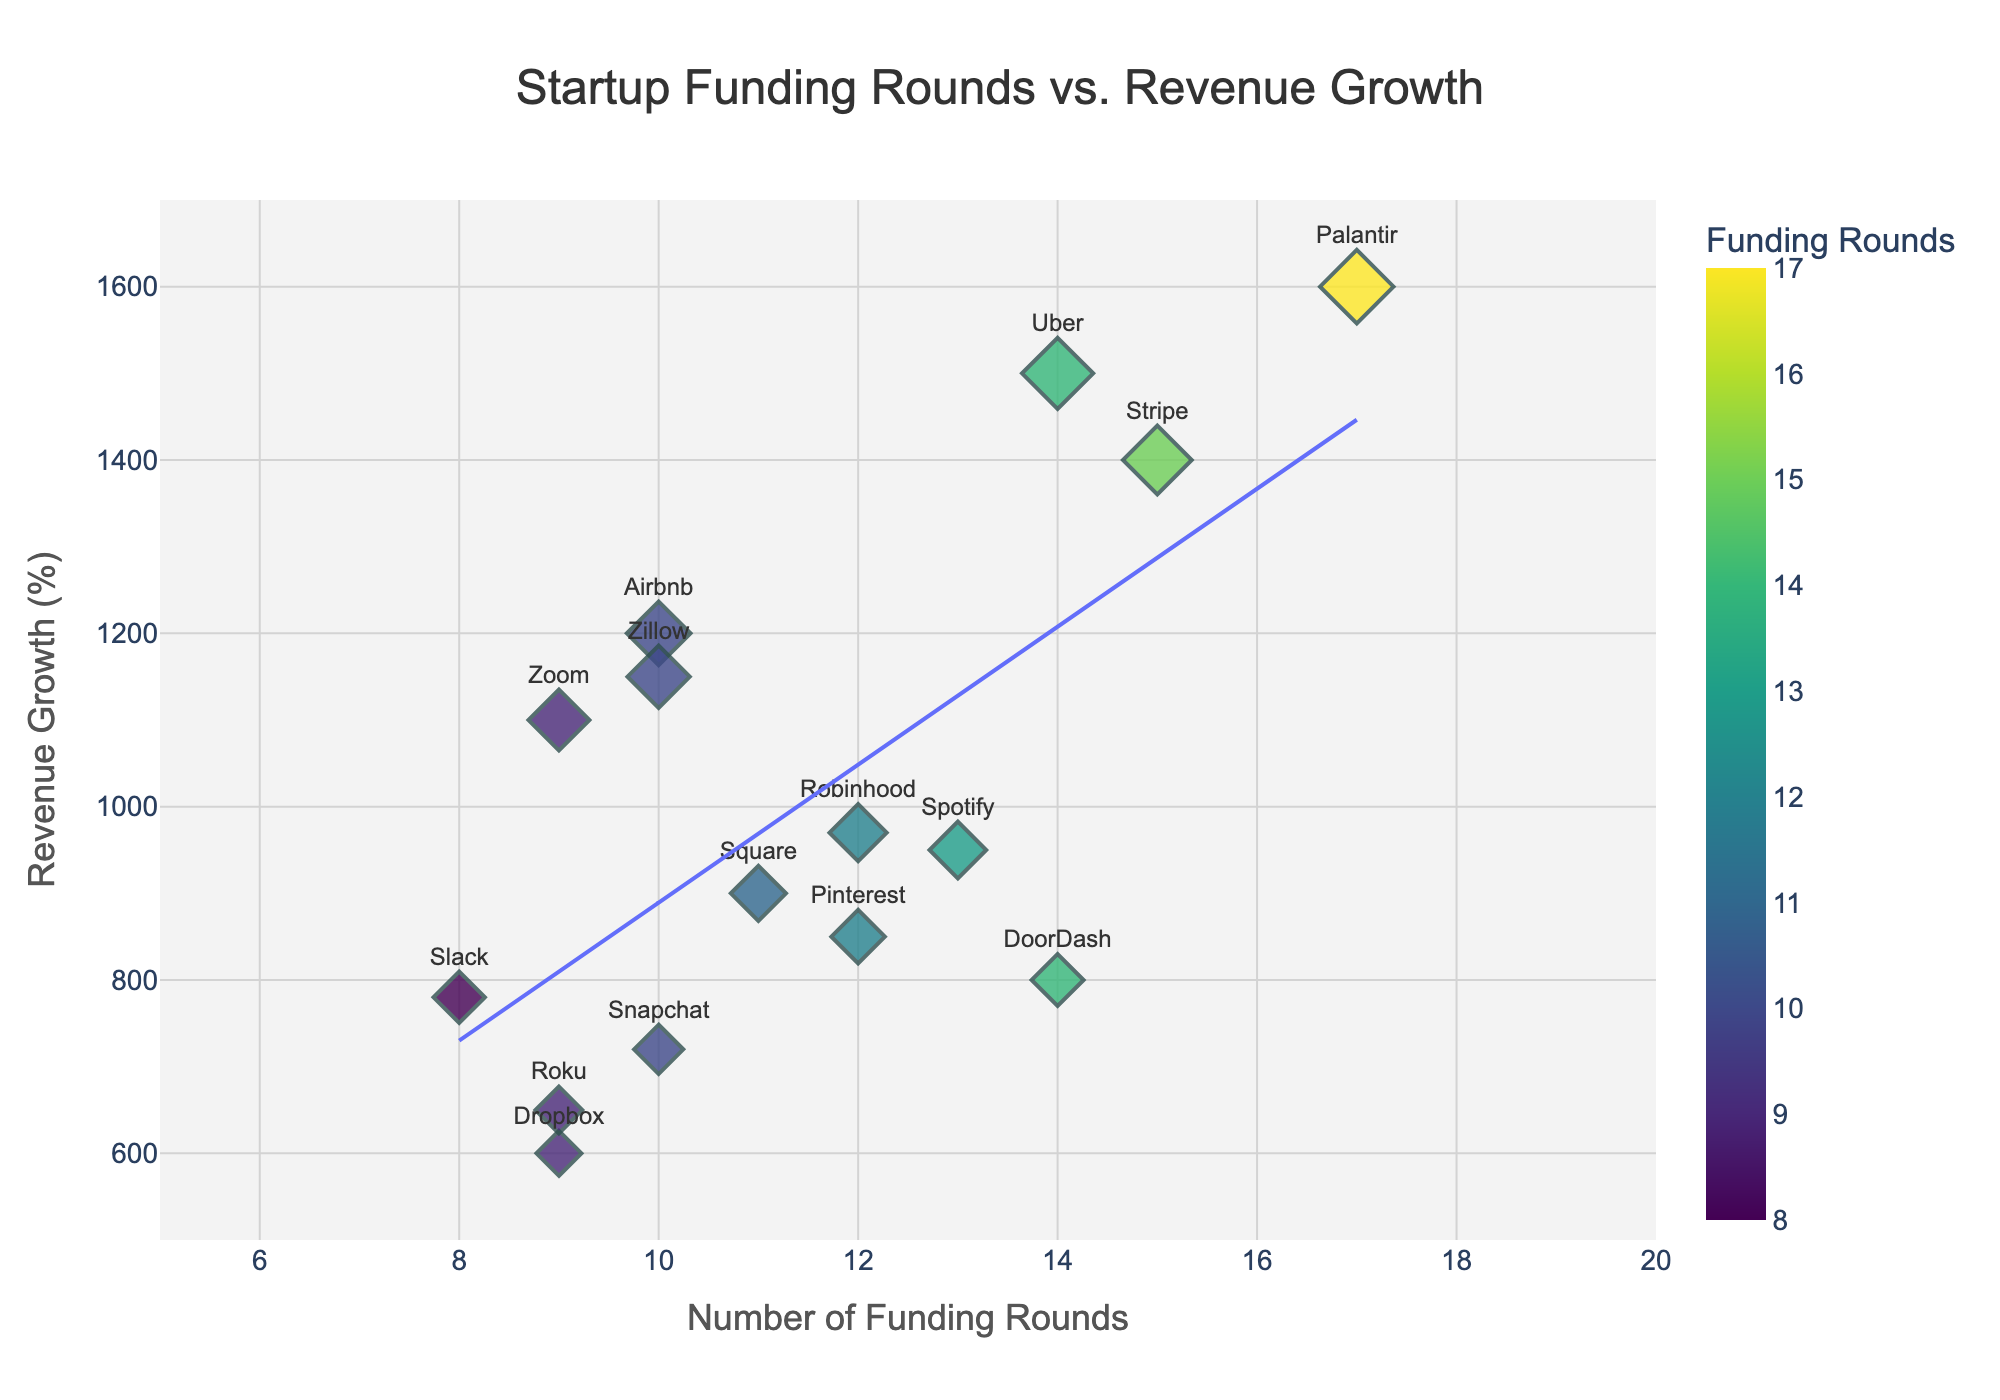What's the title of the figure? The title is usually positioned at the top center of the figure. Here, it reads, "Startup Funding Rounds vs. Revenue Growth".
Answer: Startup Funding Rounds vs. Revenue Growth How many companies have 14 funding rounds? By examining the x-axis at the "14" marker, we can see data points representing Uber and DoorDash. Therefore, there are 2 companies.
Answer: 2 What is the average revenue growth of companies with 10 funding rounds? Identify the revenue growth values for companies with 10 funding rounds: Airbnb (1200), Snapchat (720), and Zillow (1150). Add them up: 1200 + 720 + 1150 = 3070. Then, divide by the number of companies (3): 3070 / 3 = 1023.33.
Answer: 1023.33 Which company has the highest revenue growth and how many funding rounds does it have? The company with the highest y-value (revenue growth) is Palantir, with a revenue growth of 1600 and it has 17 funding rounds.
Answer: Palantir, 17 Are there more companies with revenue growth above or below 1000? Count the companies above and below the y-value of 1000. Above: Palantir, Uber, Stripe, Airbnb, Zoom, Robinhood, and Zillow (7 companies). Below: Dropbox, Snapchat, Pinterest, Spotify, Square, Slack, Roku, and DoorDash (8 companies). There are more companies below 1000.
Answer: Below Is there a positive correlation between the number of funding rounds and revenue growth? Observe the general trend of the scatter plot, including the added trend line. The trend line goes upward, showing a positive correlation.
Answer: Yes What is the revenue growth difference between Uber and Spotify? Identify the y-values for Uber (1500) and Spotify (950). Subtract the smaller revenue growth from the larger: 1500 - 950 = 550.
Answer: 550 Which company has the lowest revenue growth and what is its value? The company with the lowest y-value (revenue growth) is Dropbox, with a revenue growth of 600.
Answer: Dropbox, 600 How many companies have revenue growth between 900 and 1200? Identify the y-values within the range 900 to 1200: Spotify (950), Square (900), Robinhood (970), Airbnb (1200), Zoom (1100), and Zillow (1150). This sums up to 6 companies.
Answer: 6 